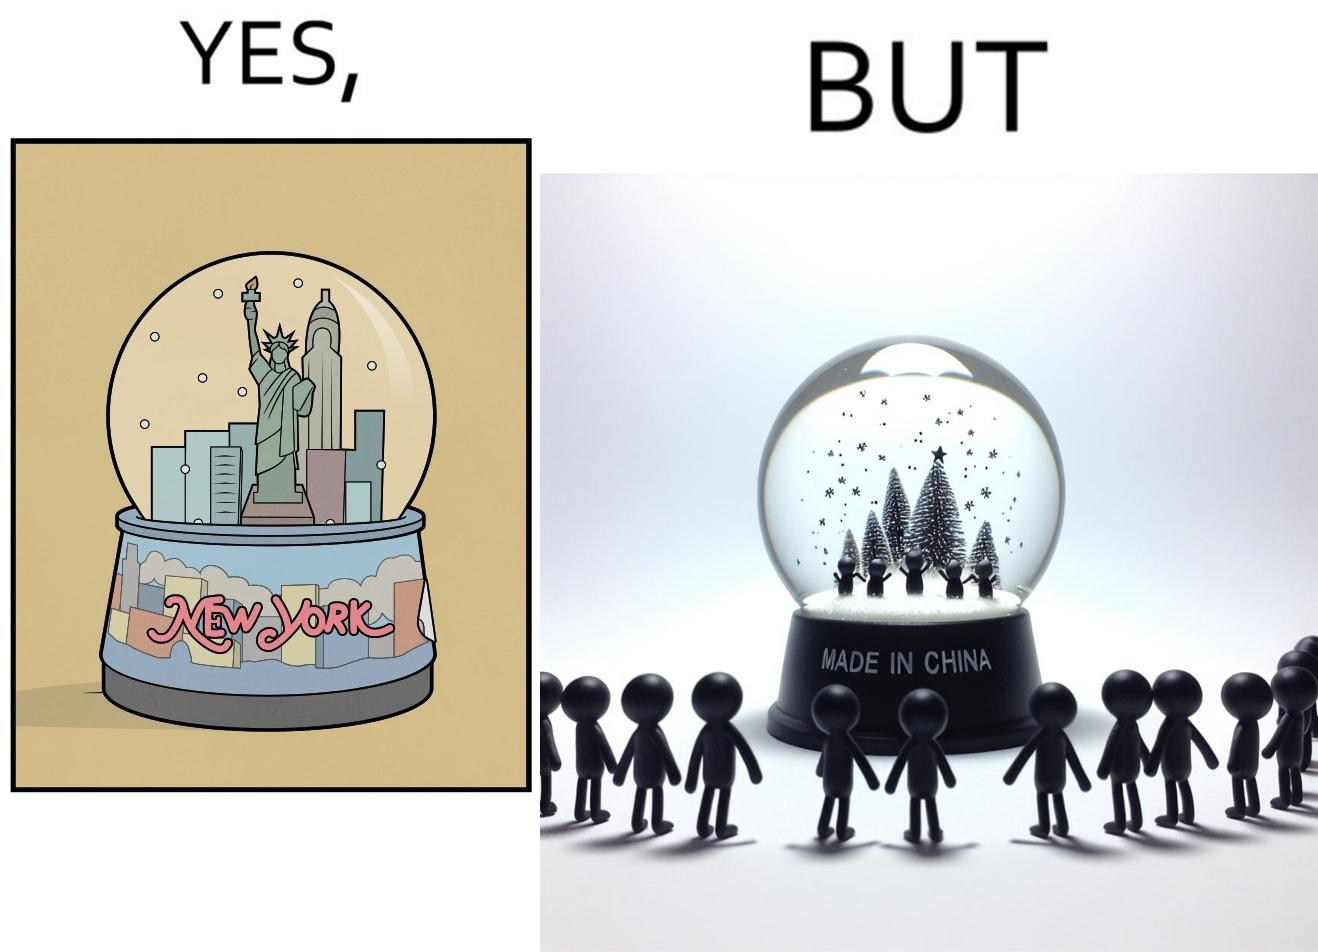Is there satirical content in this image? Yes, this image is satirical. 